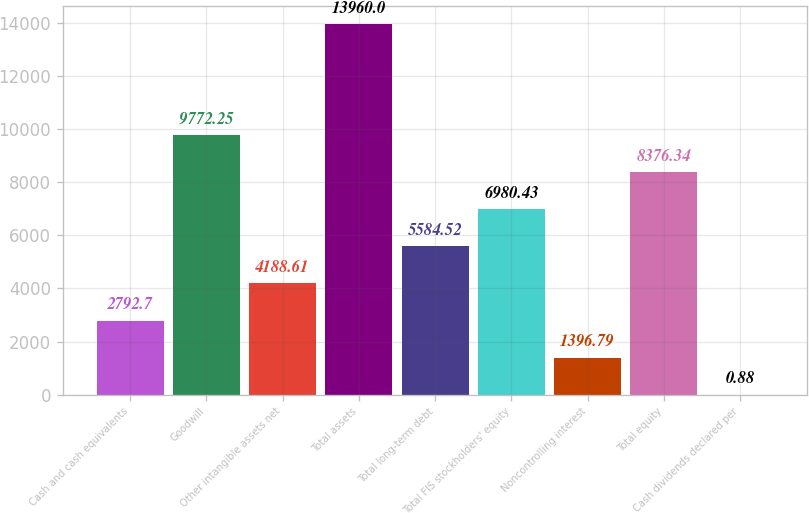Convert chart to OTSL. <chart><loc_0><loc_0><loc_500><loc_500><bar_chart><fcel>Cash and cash equivalents<fcel>Goodwill<fcel>Other intangible assets net<fcel>Total assets<fcel>Total long-term debt<fcel>Total FIS stockholders' equity<fcel>Noncontrolling interest<fcel>Total equity<fcel>Cash dividends declared per<nl><fcel>2792.7<fcel>9772.25<fcel>4188.61<fcel>13960<fcel>5584.52<fcel>6980.43<fcel>1396.79<fcel>8376.34<fcel>0.88<nl></chart> 